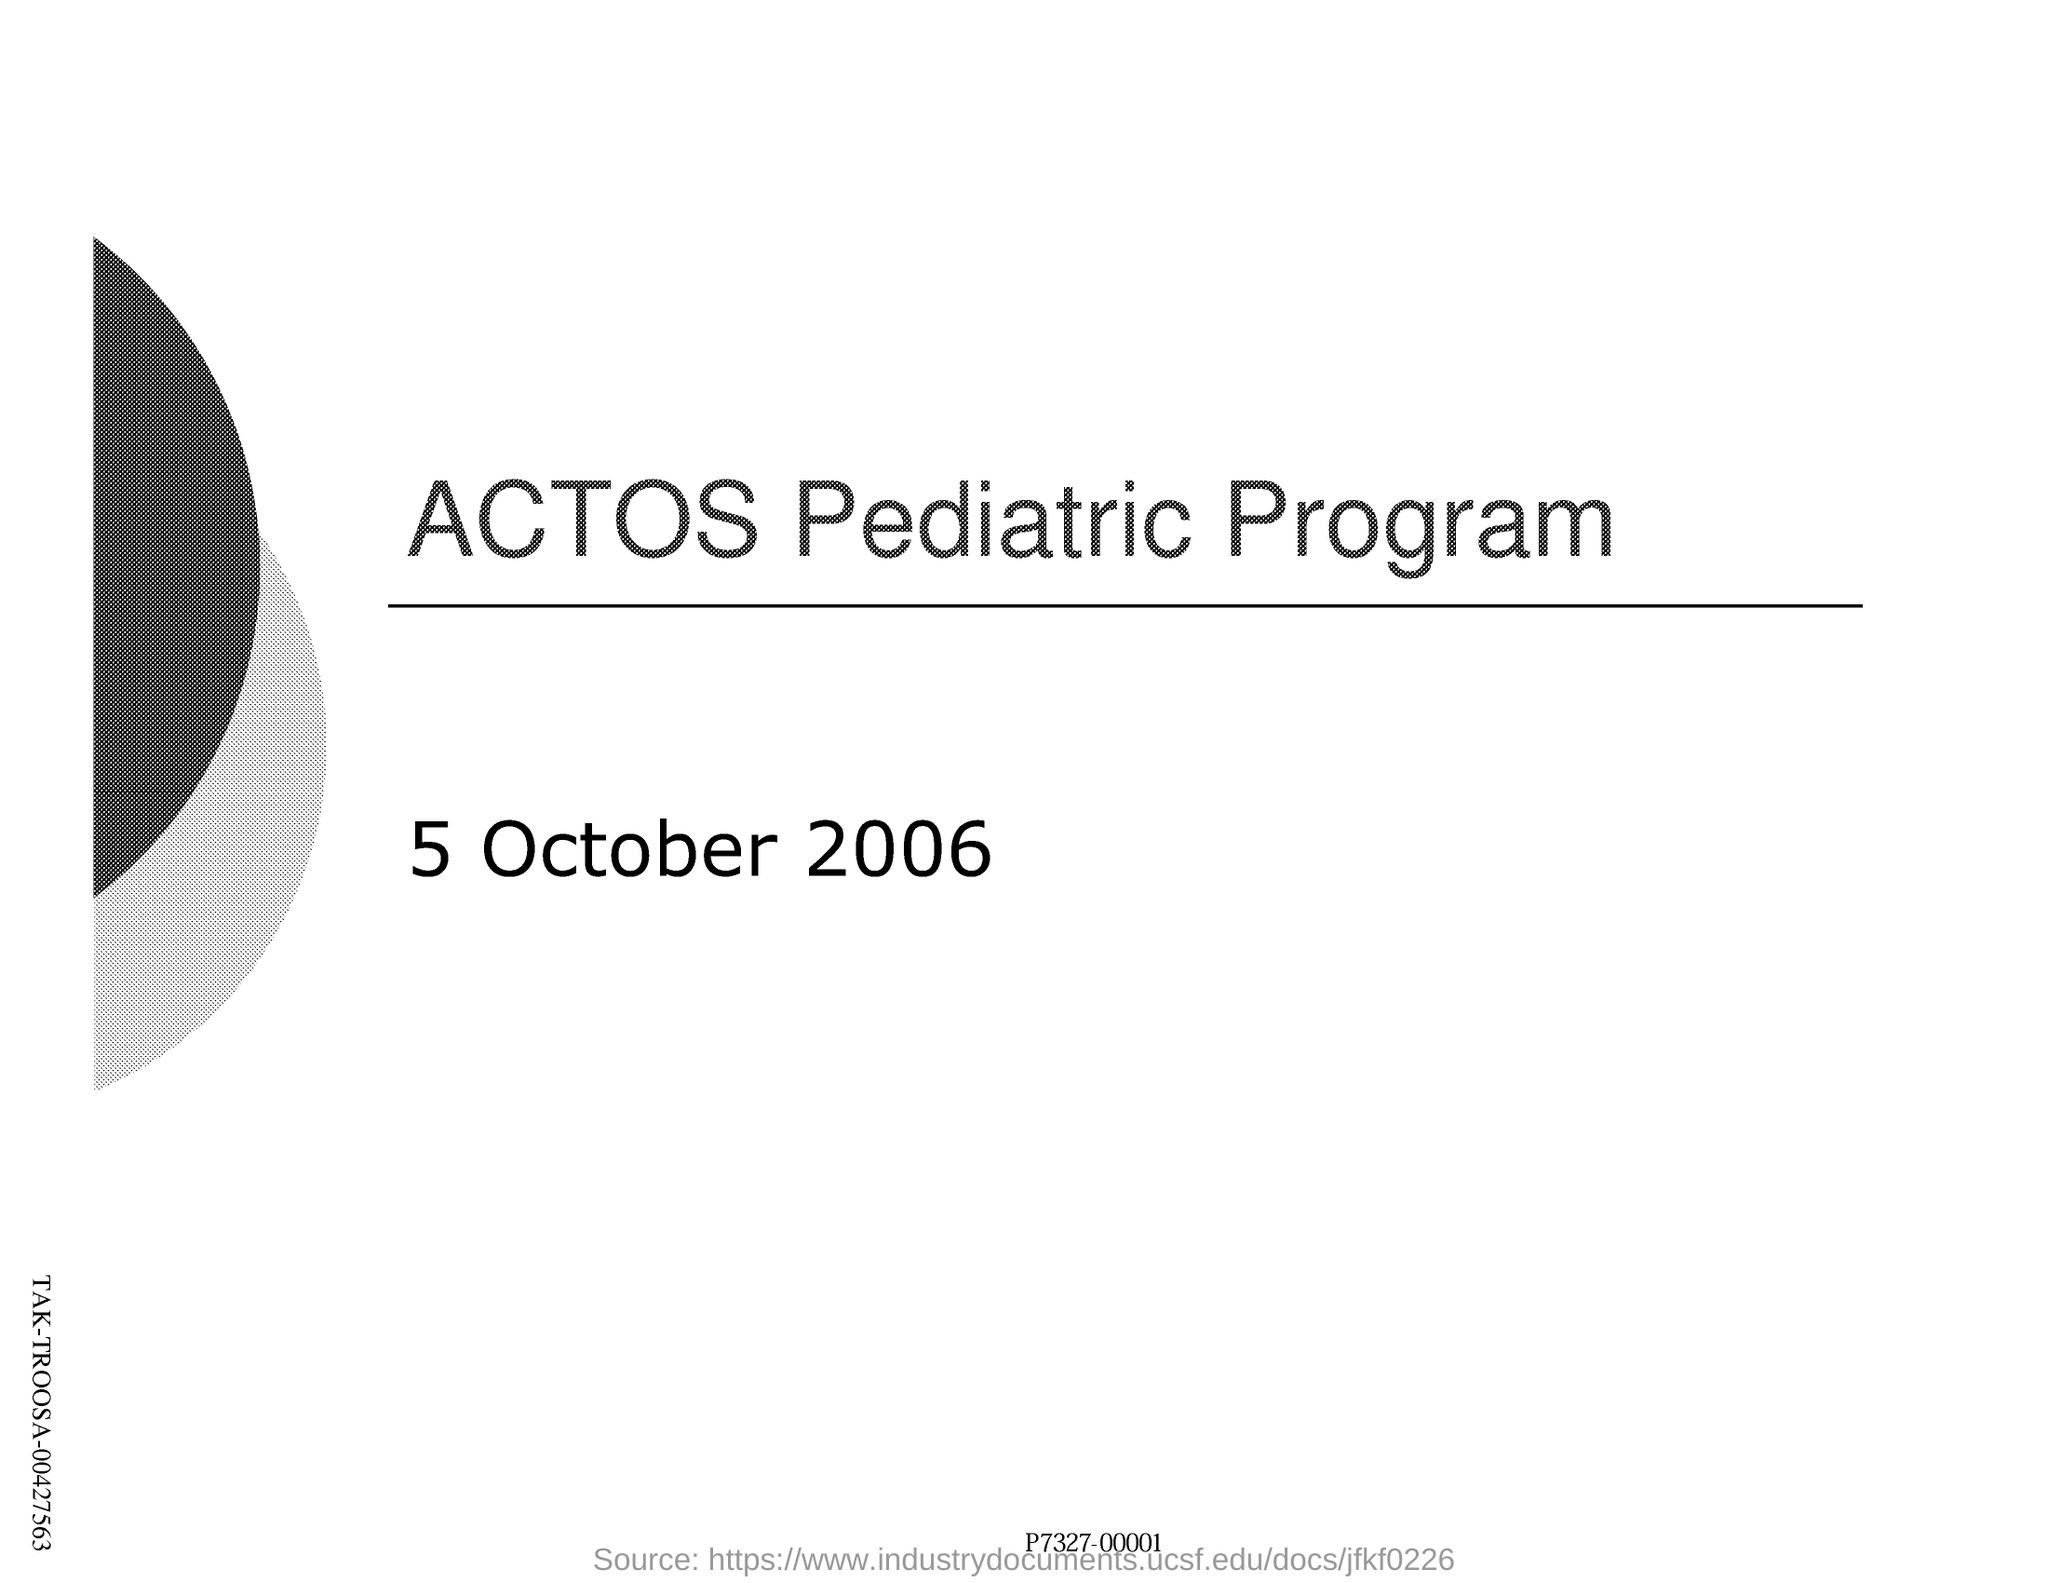What is the name of pediatric program?
Offer a terse response. ACTOS. What is the date mentioned in this page?
Keep it short and to the point. 5 October 2006. 